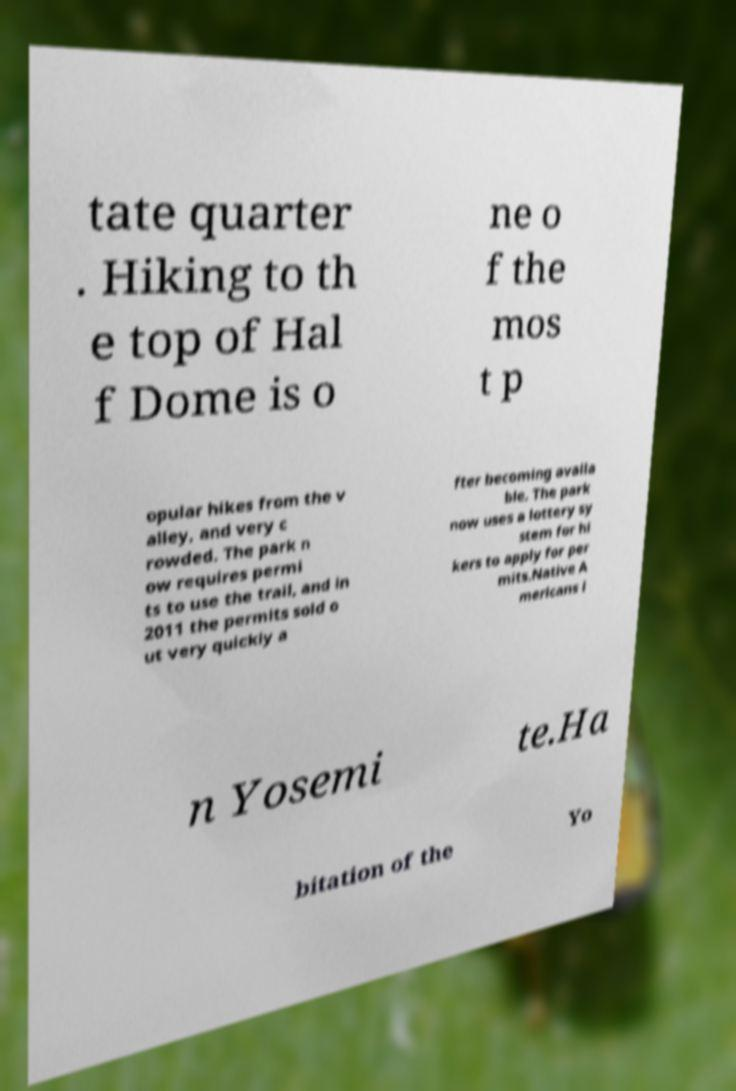I need the written content from this picture converted into text. Can you do that? tate quarter . Hiking to th e top of Hal f Dome is o ne o f the mos t p opular hikes from the v alley, and very c rowded. The park n ow requires permi ts to use the trail, and in 2011 the permits sold o ut very quickly a fter becoming availa ble. The park now uses a lottery sy stem for hi kers to apply for per mits.Native A mericans i n Yosemi te.Ha bitation of the Yo 